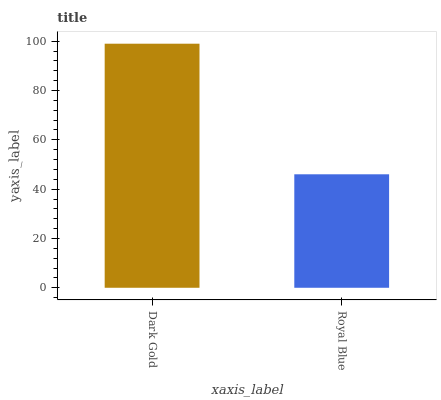Is Royal Blue the minimum?
Answer yes or no. Yes. Is Dark Gold the maximum?
Answer yes or no. Yes. Is Royal Blue the maximum?
Answer yes or no. No. Is Dark Gold greater than Royal Blue?
Answer yes or no. Yes. Is Royal Blue less than Dark Gold?
Answer yes or no. Yes. Is Royal Blue greater than Dark Gold?
Answer yes or no. No. Is Dark Gold less than Royal Blue?
Answer yes or no. No. Is Dark Gold the high median?
Answer yes or no. Yes. Is Royal Blue the low median?
Answer yes or no. Yes. Is Royal Blue the high median?
Answer yes or no. No. Is Dark Gold the low median?
Answer yes or no. No. 